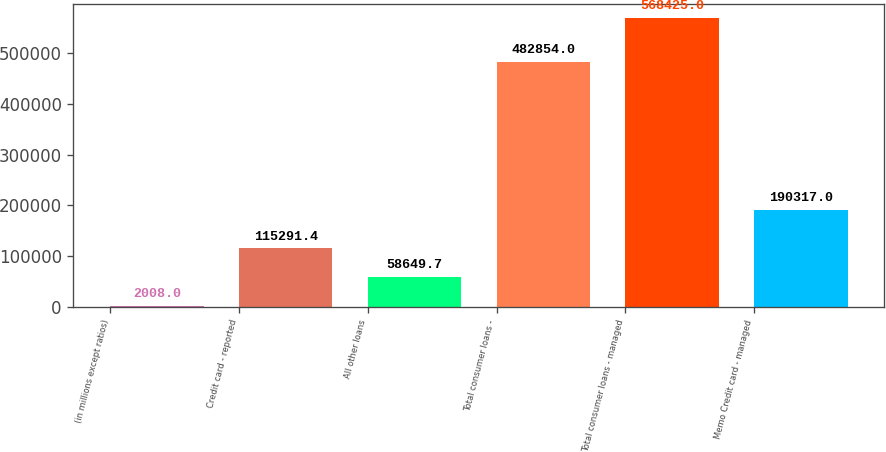<chart> <loc_0><loc_0><loc_500><loc_500><bar_chart><fcel>(in millions except ratios)<fcel>Credit card - reported<fcel>All other loans<fcel>Total consumer loans -<fcel>Total consumer loans - managed<fcel>Memo Credit card - managed<nl><fcel>2008<fcel>115291<fcel>58649.7<fcel>482854<fcel>568425<fcel>190317<nl></chart> 